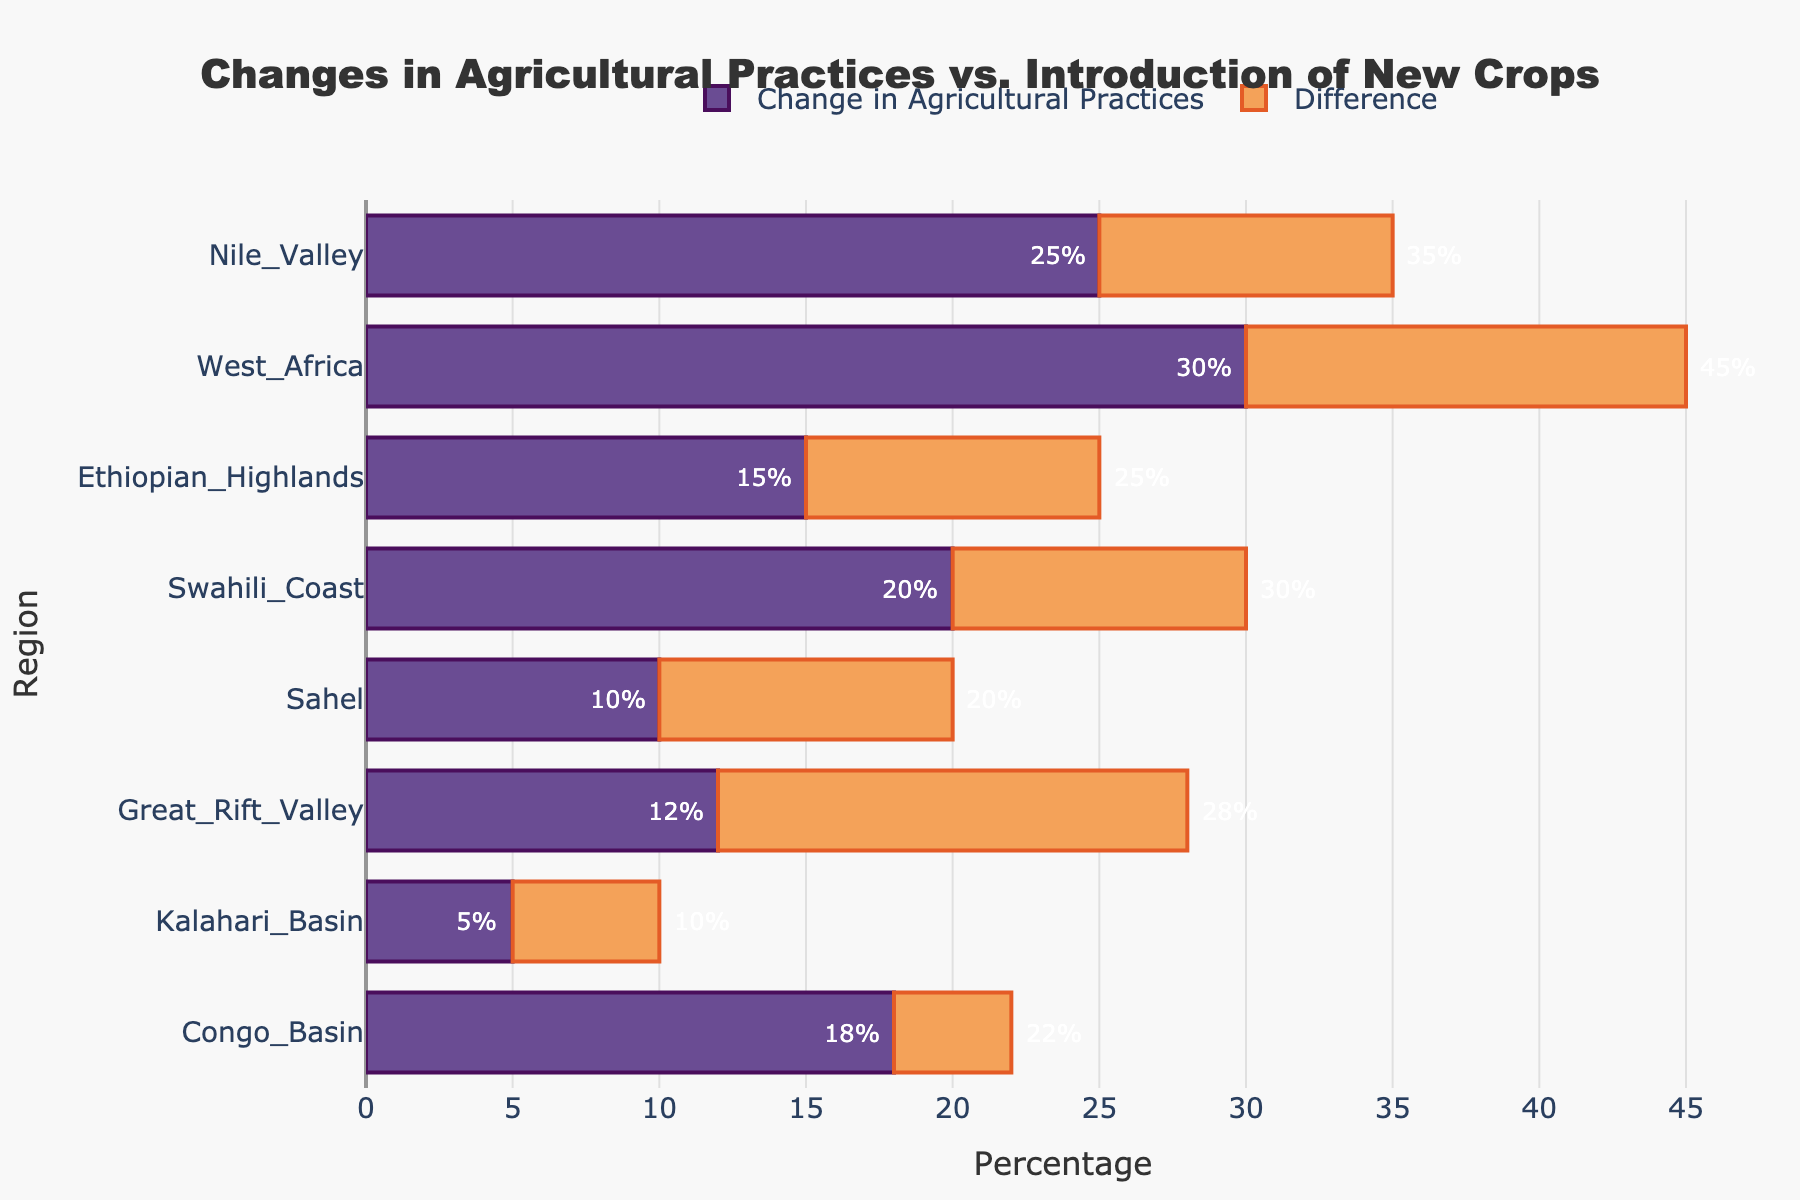How many regions have more than 20% Introduction of New Crops? By examining the annotations and lengths of the bars, we can see the specific percentage values for Introduction of New Crops in each region. The regions with more than 20% Introduction of New Crops are Nile Valley (35%), West Africa (45%), Ethiopian Highlands (25%), Swahili Coast (30%), Great Rift Valley (28%), and Congo Basin (22%). In total, there are 6 regions.
Answer: 6 Which region shows the largest difference between the Introduction of New Crops and Change in Agricultural Practices? To determine this, we need to look at the length of the 'Difference' bars. West Africa has the largest Difference bar, indicating the largest gap, which is (45% - 30%) = 15%.
Answer: West Africa What is the total percentage of Change in Agricultural Practices for all regions combined? Sum up the Change in Agricultural Practices percentages for all regions: 25 + 30 + 15 + 20 + 10 + 12 + 5 + 18 = 135.
Answer: 135% Which regions have a Difference value equal to or less than 10%? We observe the length of the 'Difference' bars. The regions with a Difference value of 10% or less are Nile Valley (10%), Ethiopian Highlands (10%), Sahel (10%), and Kalahari Basin (5%).
Answer: Nile Valley, Ethiopian Highlands, Sahel, Kalahari Basin What is the average Introduction of New Crops percentage across all regions? Average is calculated as the sum of the Introduction of New Crops percentages divided by the number of regions. The sum is 35 + 45 + 25 + 30 + 20 + 28 + 10 + 22 = 215, and there are 8 regions. So, 215 / 8 = 26.875%.
Answer: 26.875% Which region has the smallest Change in Agricultural Practices percentage? By checking the smallest bar in the 'Change in Agricultural Practices' group, Kalahari Basin has the smallest value of 5%.
Answer: Kalahari Basin Compare the agricultural changes between the Nile Valley and the Swahili Coast. Which one has a higher Change in Agricultural Practices percentage? From the chart, we see that Nile Valley has a Change in Agricultural Practices percentage of 25% while Swahili Coast has 20%. Thus, Nile Valley has a higher value.
Answer: Nile Valley How much higher is the Introduction of New Crops percentage in West Africa compared to the Sahel? West Africa's Introduction of New Crops percentage is 45%, and Sahel's is 20%. The difference is 45% - 20% = 25%.
Answer: 25% Does any region have equal percentages for both Change in Agricultural Practices and Introduction of New Crops? By scrutinizing the values, we can see that no regions have equal values for both metrics. Each region shows a difference.
Answer: No 